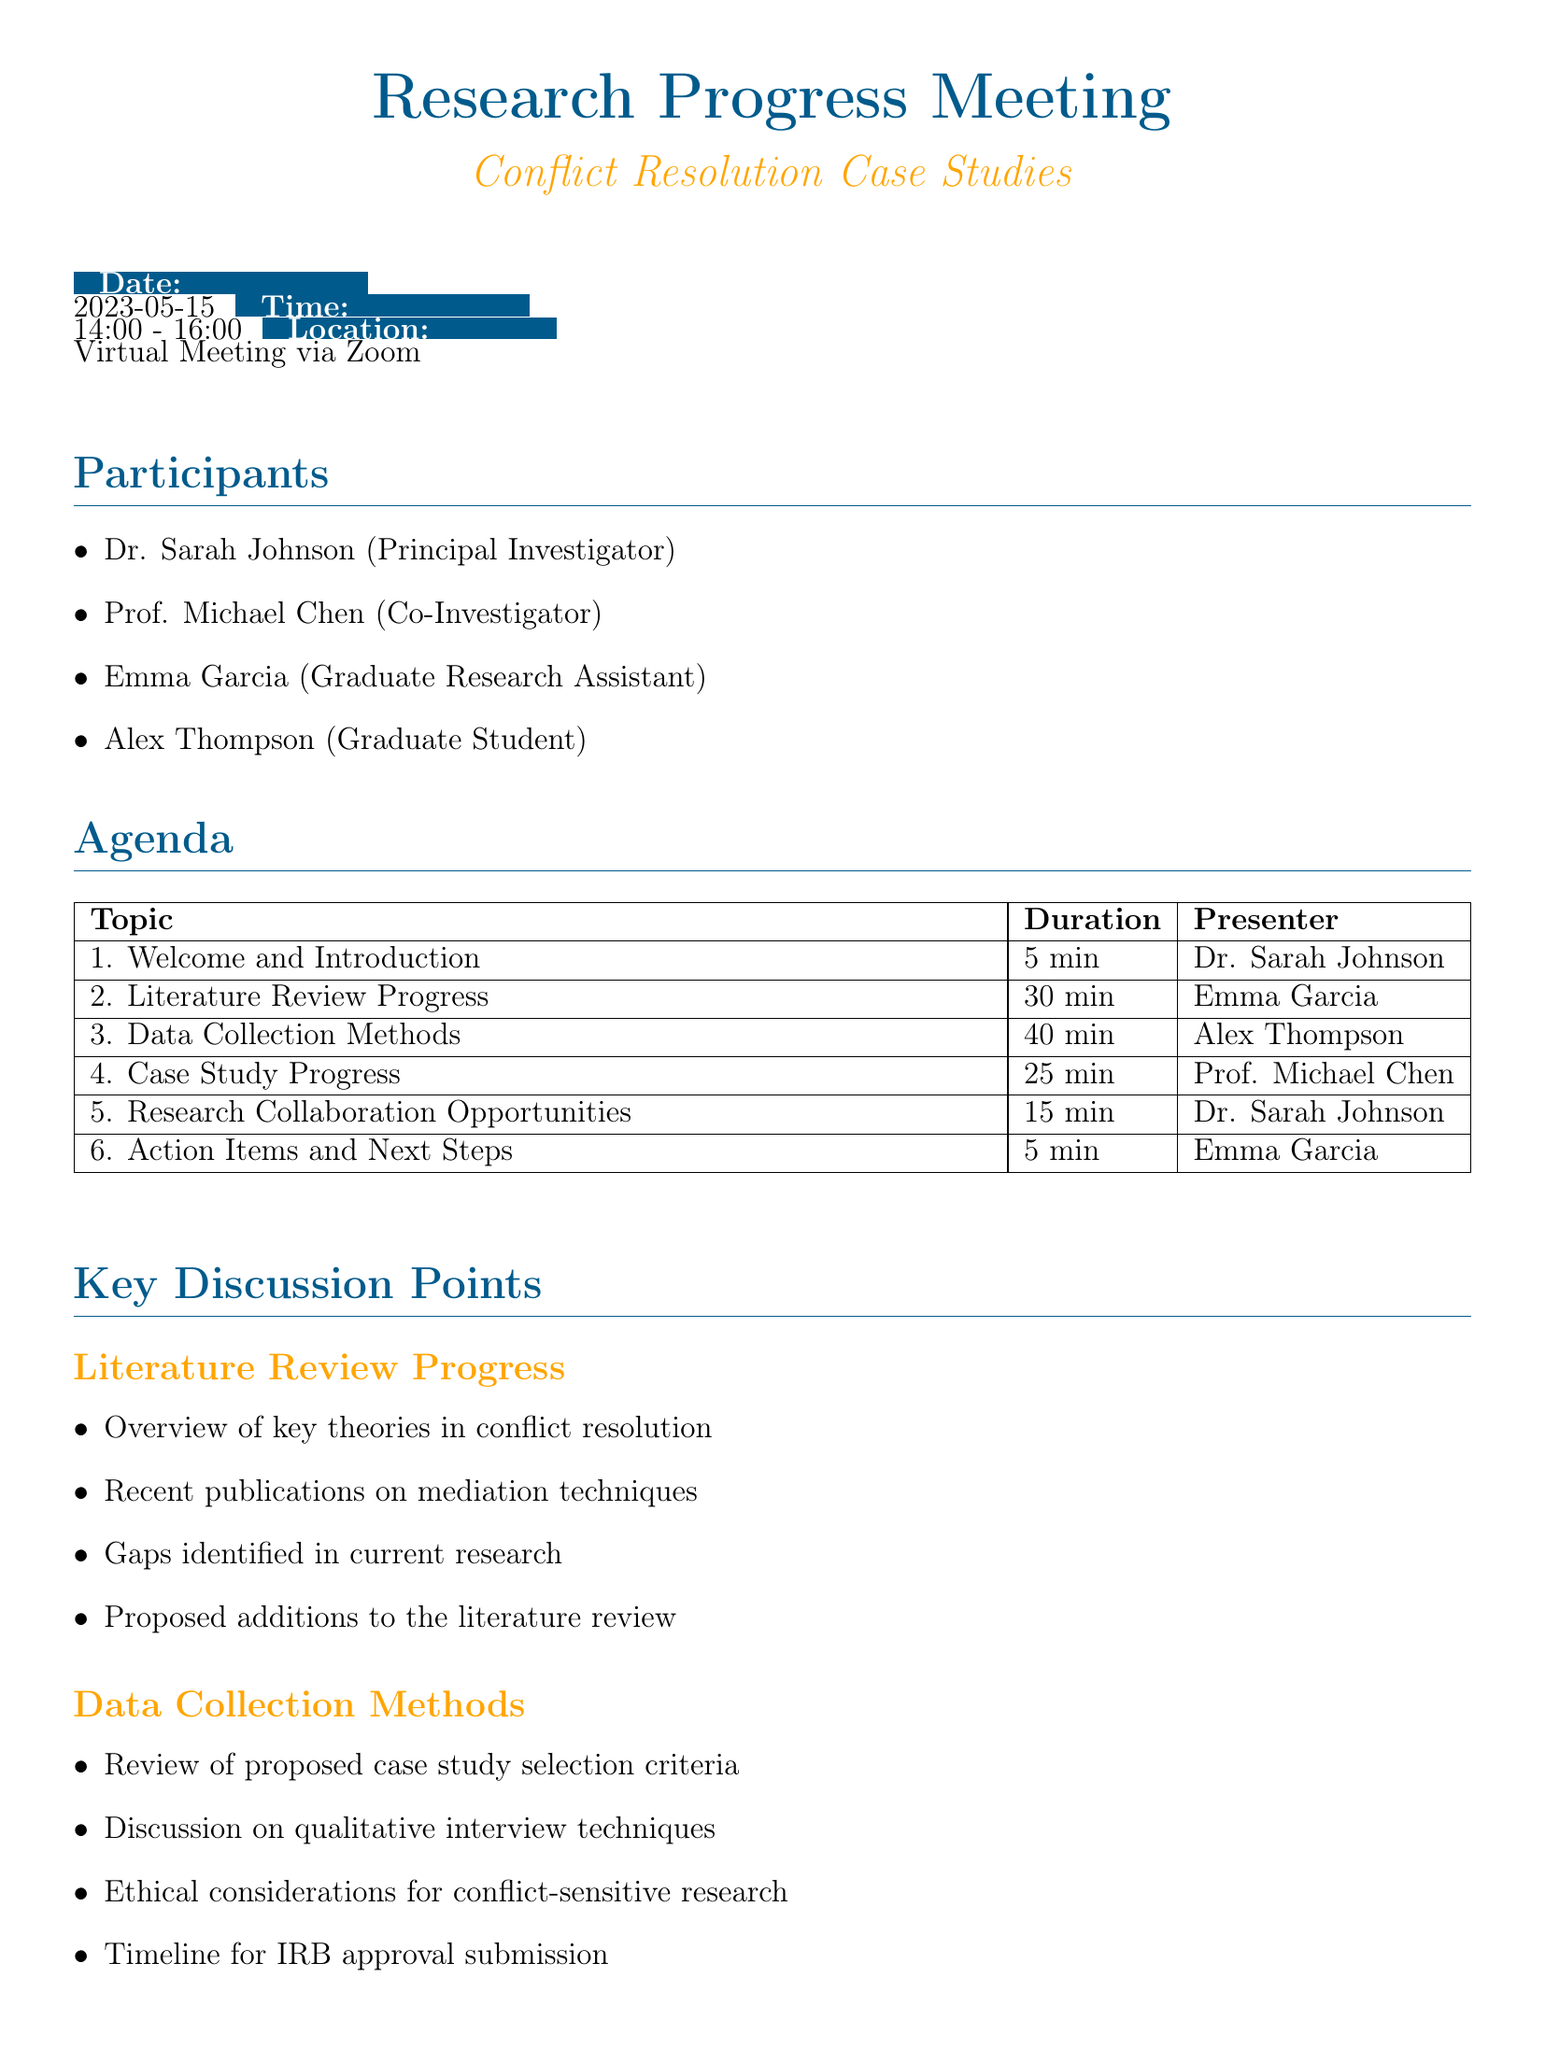What is the meeting title? The meeting title is mentioned at the beginning of the document, which is "Research Progress Meeting on Conflict Resolution Case Studies."
Answer: Research Progress Meeting on Conflict Resolution Case Studies Who is the presenter for the Literature Review Progress? The presenter for the Literature Review Progress can be found in the agenda section where Emma Garcia is listed as the presenter.
Answer: Emma Garcia How long does the Data Collection Methods discussion last? The duration of the Data Collection Methods segment is specified in the agenda table, which states it lasts for 40 minutes.
Answer: 40 minutes What are the ethical considerations mentioned for data collection? Ethical considerations are outlined under the Data Collection Methods section, highlighting the importance of conducting conflict-sensitive research.
Answer: Conflict-sensitive research What is one proposed addition to the literature review? The proposed additions to the literature review can be found in the subtopics under the Literature Review Progress, which discusses potential gaps and what to include next.
Answer: Proposed additions to the literature review What is the required resource related to the zoom meeting? The resources needed section lists a Zoom meeting link as necessary for the meeting.
Answer: Zoom meeting link How many participants are attending the meeting? The number of participants can be counted from the list provided, indicating a total of four individuals attending.
Answer: Four What task needs to be completed within 48 hours? The follow-up tasks specify that circulating meeting minutes needs to be done within 48 hours after the meeting.
Answer: Circulate meeting minutes What conference is mentioned in the Research Collaboration Opportunities? One of the items listed under Research Collaboration Opportunities includes the International Association for Conflict Management (IACM) conference.
Answer: International Association for Conflict Management (IACM) 